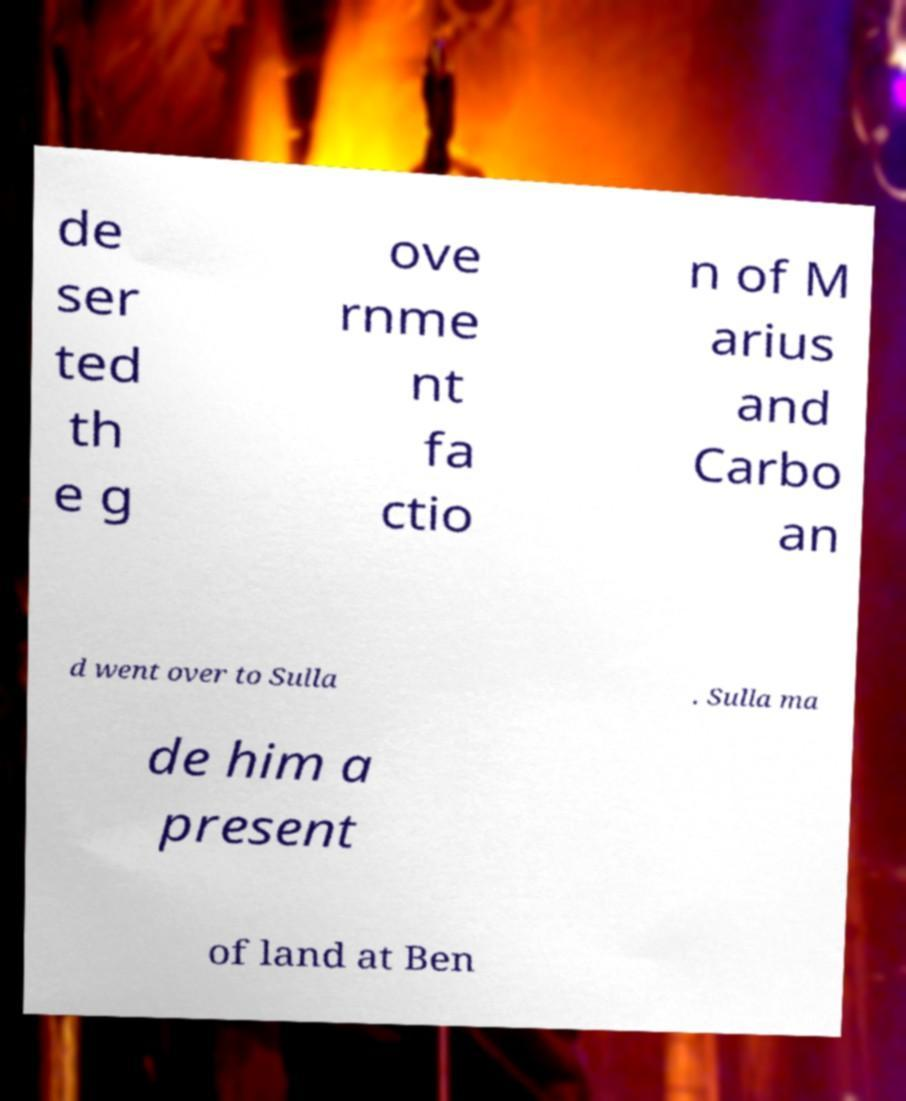There's text embedded in this image that I need extracted. Can you transcribe it verbatim? de ser ted th e g ove rnme nt fa ctio n of M arius and Carbo an d went over to Sulla . Sulla ma de him a present of land at Ben 